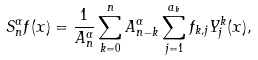<formula> <loc_0><loc_0><loc_500><loc_500>S _ { n } ^ { \alpha } f ( x ) = \frac { 1 } { A _ { n } ^ { \alpha } } \sum _ { k = 0 } ^ { n } A _ { n - k } ^ { \alpha } \sum _ { j = 1 } ^ { a _ { k } } f _ { k , j } Y _ { j } ^ { k } ( x ) ,</formula> 